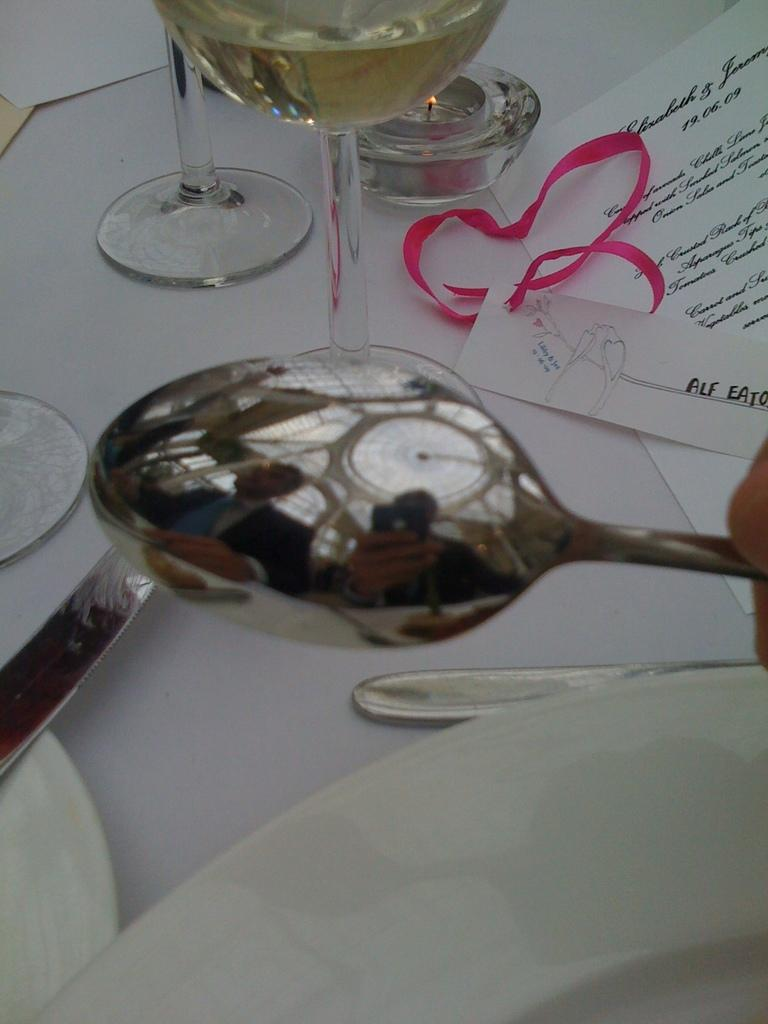What type of tableware can be seen in the image? There are glasses, spoons, and plates in the image. What else is present in the image besides tableware? There is a piece of paper with text in the image. Where is the nest of dinosaurs located in the image? There is no nest of dinosaurs present in the image. What type of coal is visible in the image? There is no coal present in the image. 